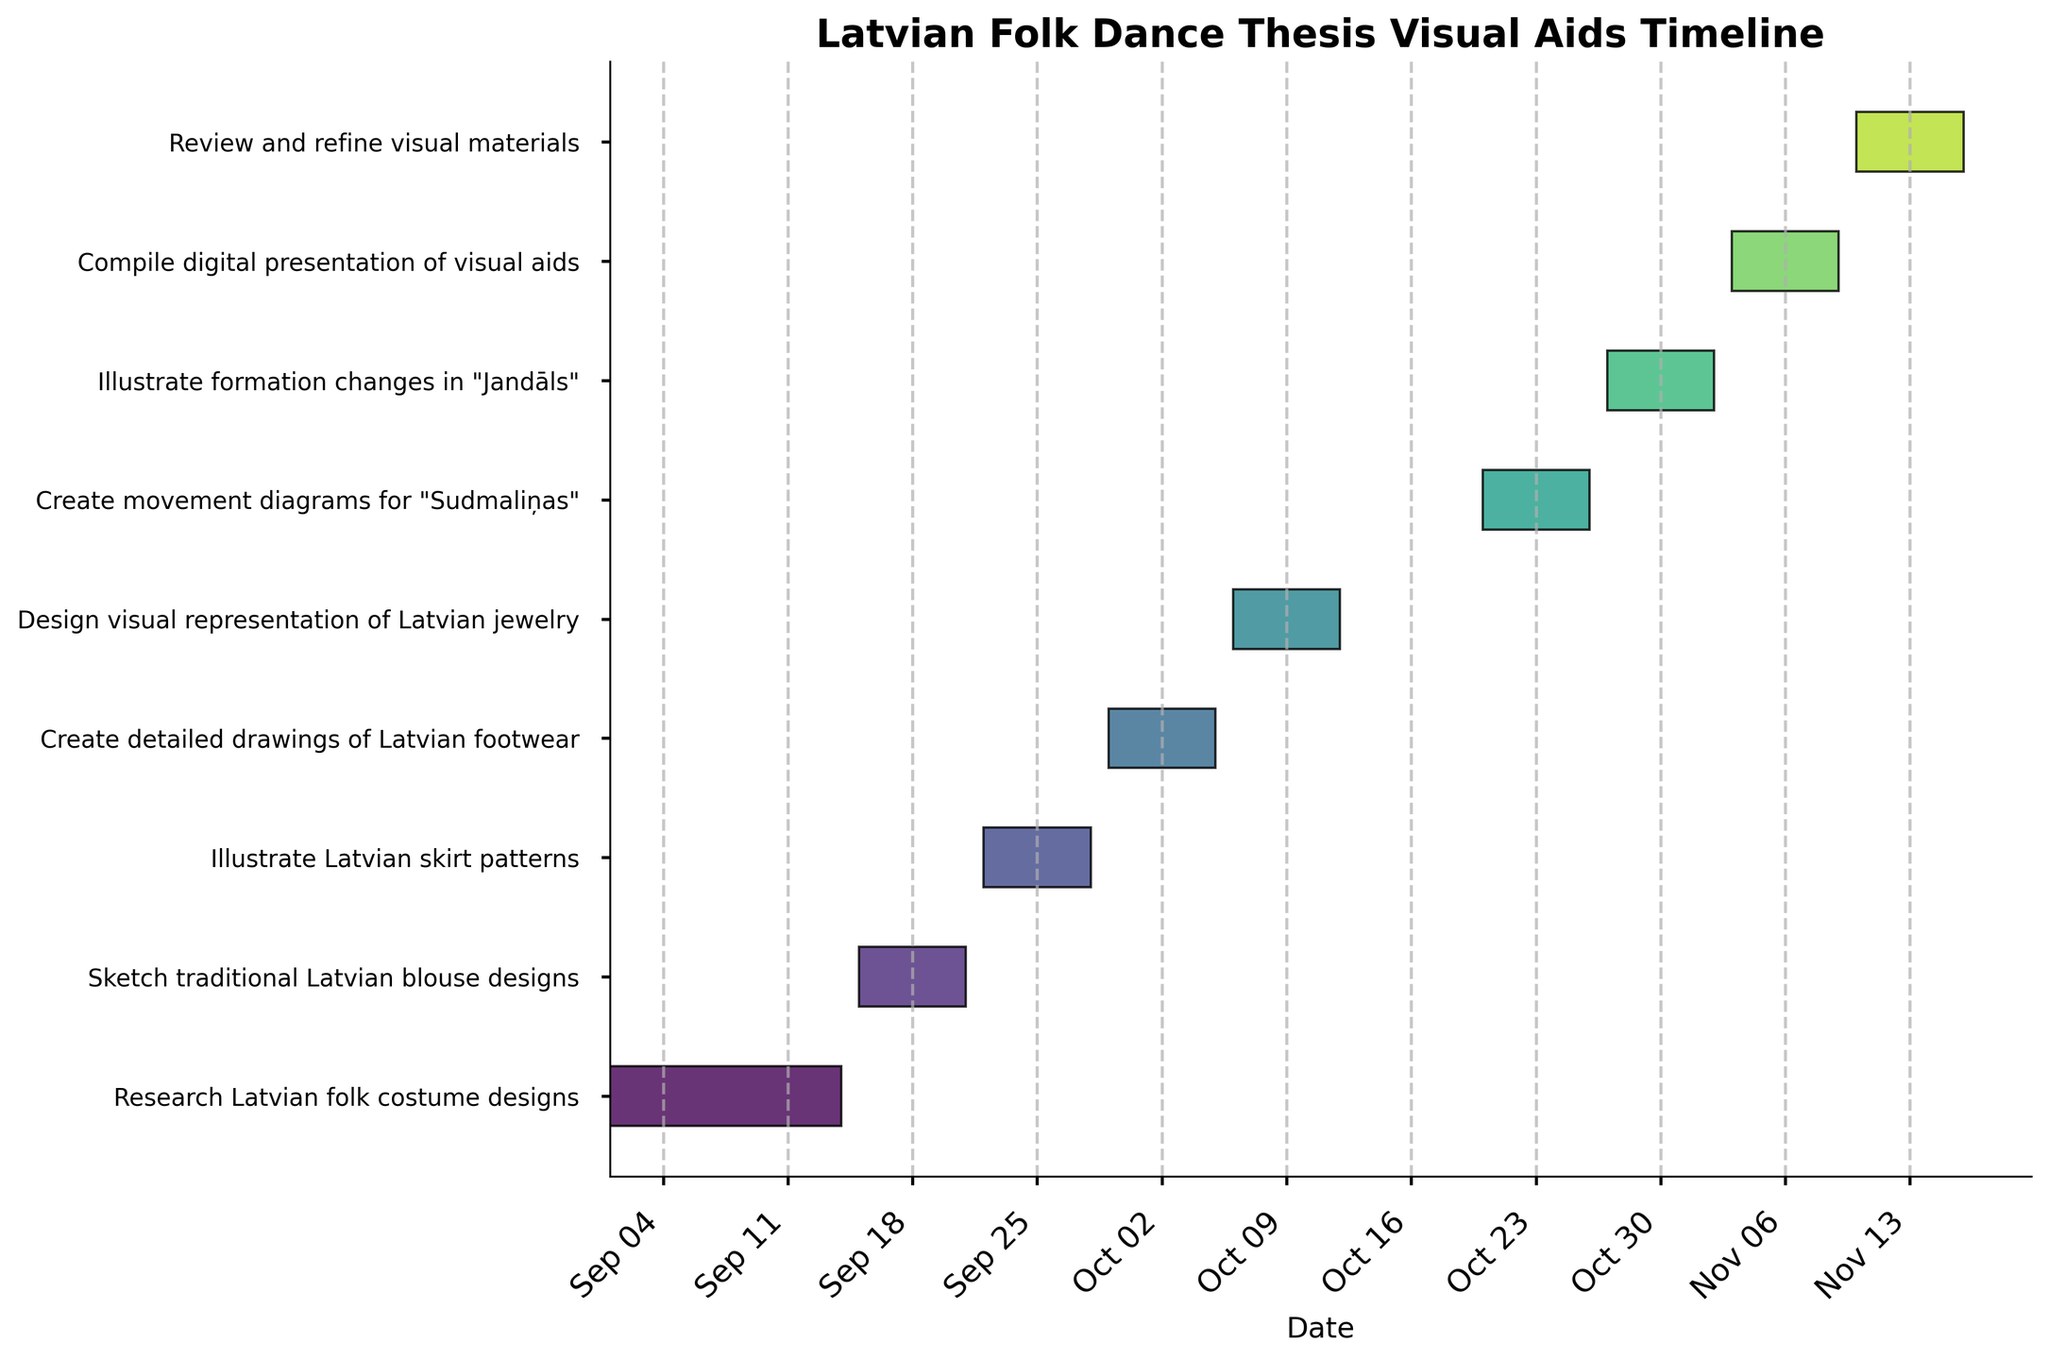What is the title of the Gantt Chart? The title is usually found at the top of the chart. In this case, it provides a summary of the timetable shown in the chart. It reads "Latvian Folk Dance Thesis Visual Aids Timeline."
Answer: Latvian Folk Dance Thesis Visual Aids Timeline How many distinct tasks are displayed on the Gantt Chart? The y-axis of the Gantt Chart lists each task individually. By counting the entries, we can determine the total number of tasks.
Answer: 9 Which task has the earliest start date? To determine the earliest starting task, look at the leftmost bar on the chart. The lowest date on the chart corresponds to the task "Research Latvian folk costume designs."
Answer: Research Latvian folk costume designs Which task spans from September 29 to October 5? To determine this, look for the bar representing a task starting on September 29 and ending on October 5. The task is "Create detailed drawings of Latvian footwear."
Answer: Create detailed drawings of Latvian footwear How many tasks are scheduled to be completed within October? Look at all the tasks and their finishing dates to determine which ones are completed in October. Count those that end before November 1st. The tasks are "Create detailed drawings of Latvian footwear" and "Design visual representation of Latvian jewelry".
Answer: 3 Which task requires the longest duration to complete? To find the longest task duration, compare the lengths of the horizontal bars. In this chart, "Research Latvian folk costume designs" spans the longest period, which is 14 days.
Answer: Research Latvian folk costume designs What is the duration of the task "Compile digital presentation of visual aids"? Examine the task bar labeled "Compile digital presentation of visual aids" and measure the length of the timeline it covers, which is from November 3 to November 9. This totals to 7 days.
Answer: 7 days Between "Create movement diagrams for 'Sudmaliņas'" and "Illustrate formation changes in 'Jandāls'", which one starts later? Compare the start dates of these two tasks. "Create movement diagrams for 'Sudmaliņas'" starts on October 20, while "Illustrate formation changes in 'Jandāls'" starts on October 27.
Answer: Illustrate formation changes in 'Jandāls' How many tasks are allocated a 7-day duration? By reviewing the duration values of the tasks, count the number that shows a 7-day duration.
Answer: 7 What is the time interval between the end of "Design visual representation of Latvian jewelry" and the start of "Create movement diagrams for 'Sudmaliņas' "? Identify the end date of "Design visual representation of Latvian jewelry" (October 12) and the start date of "Create movement diagrams for 'Sudmaliņas'" (October 20). The interval between these two dates is 8 days.
Answer: 8 days 